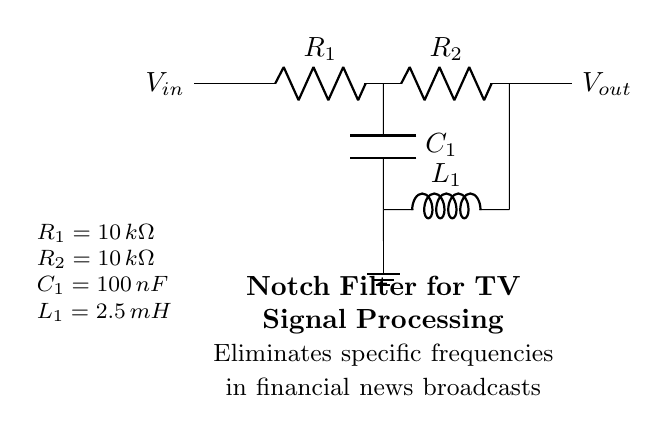What is the type of filter represented in the circuit? The circuit represents a notch filter, which is specifically designed to eliminate a narrow bandwidth of frequencies. This is indicated by the presence of both capacitors and inductors arranged in a specific configuration that is characteristic of notch filters.
Answer: Notch filter What is the resistance value of R1? The resistance value of R1 is indicated in the diagram, where it shows that R1 equals ten kiloohms. This value is part of the circuit and helps define the filtering characteristics of the notch filter.
Answer: Ten kiloohms What is the function of capacitor C1 in the notch filter? Capacitor C1 works with the inductance of L1 to set up a resonant circuit that defines the notch filter's response at specific frequencies. It blocks certain frequencies while allowing others to pass, thus playing a crucial role in the filtering action.
Answer: To set a resonant frequency How many resistors are present in the circuit? The circuit contains two resistors, R1 and R2, which are part of the filtering mechanism and contribute to the notch filter's functionality. The configuration of both resistors aids in determining the overall impedance at the notch frequency.
Answer: Two What is the inductance value of L1? The inductance value of L1 is provided in the circuit diagram, stating that L1 is equal to 2.5 millihenries. This component, along with the capacitors, is responsible for the frequency-selective behavior of the notch filter.
Answer: Two point five millihenries What do R2 and R1 have in common? Both R2 and R1 share the same resistance value of ten kiloohms, which is critical in maintaining consistent performance within the notch filter. Equal resistance helps balance the circuit and can influence its frequency response.
Answer: Same resistance value Which component is connected to ground in the circuit? The component connected to ground is the bottom terminal of capacitor C1, which establishes a reference point in the circuit. This grounding is essential for ensuring proper operation and installation of the notch filter.
Answer: Capacitor C1 